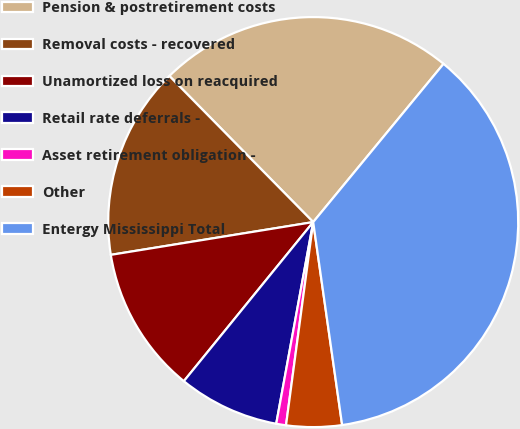Convert chart. <chart><loc_0><loc_0><loc_500><loc_500><pie_chart><fcel>Pension & postretirement costs<fcel>Removal costs - recovered<fcel>Unamortized loss on reacquired<fcel>Retail rate deferrals -<fcel>Asset retirement obligation -<fcel>Other<fcel>Entergy Mississippi Total<nl><fcel>23.34%<fcel>15.18%<fcel>11.58%<fcel>7.98%<fcel>0.77%<fcel>4.37%<fcel>36.78%<nl></chart> 